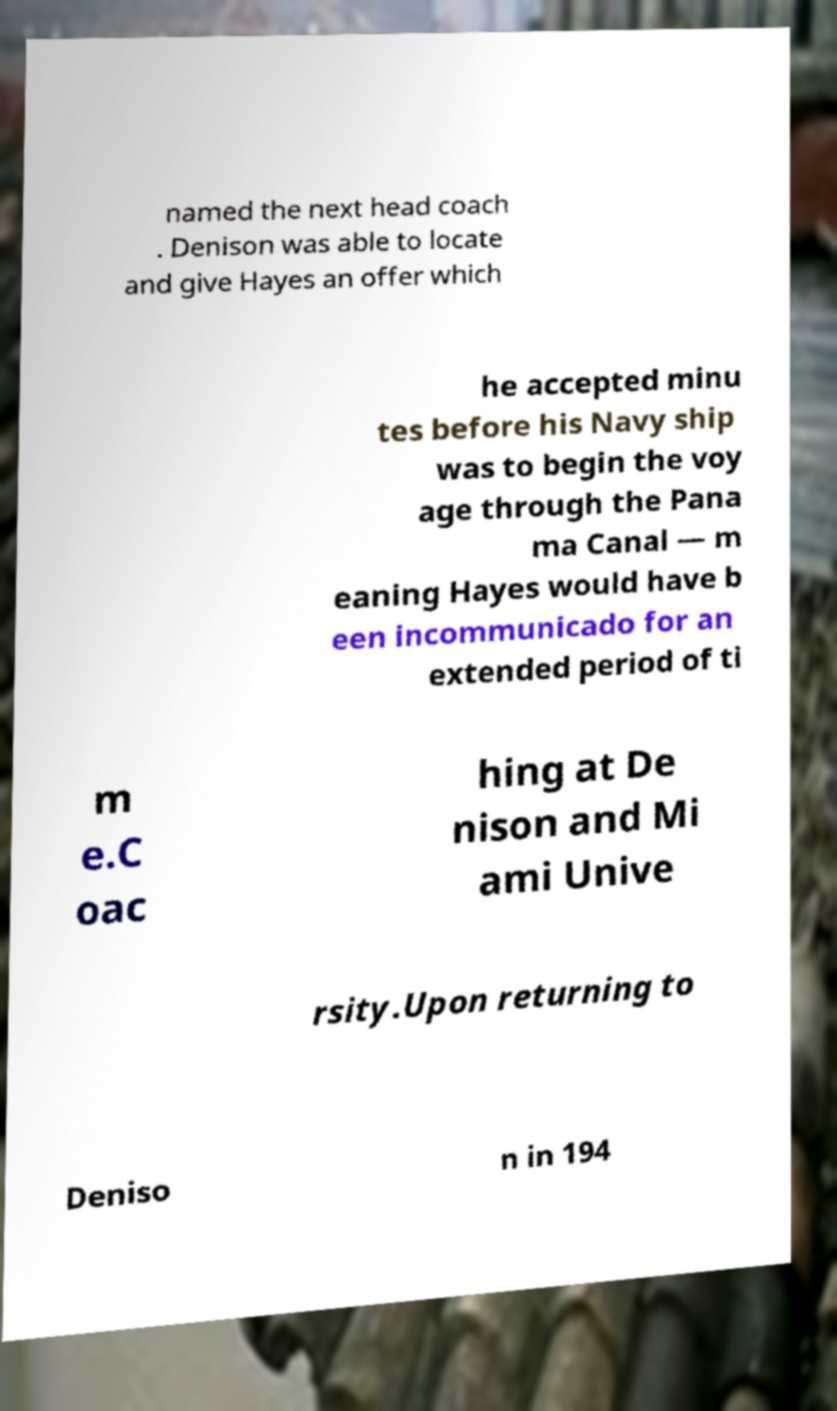Can you accurately transcribe the text from the provided image for me? named the next head coach . Denison was able to locate and give Hayes an offer which he accepted minu tes before his Navy ship was to begin the voy age through the Pana ma Canal — m eaning Hayes would have b een incommunicado for an extended period of ti m e.C oac hing at De nison and Mi ami Unive rsity.Upon returning to Deniso n in 194 